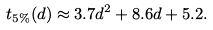<formula> <loc_0><loc_0><loc_500><loc_500>t _ { 5 \% } ( d ) \approx 3 . 7 d ^ { 2 } + 8 . 6 d + 5 . 2 .</formula> 